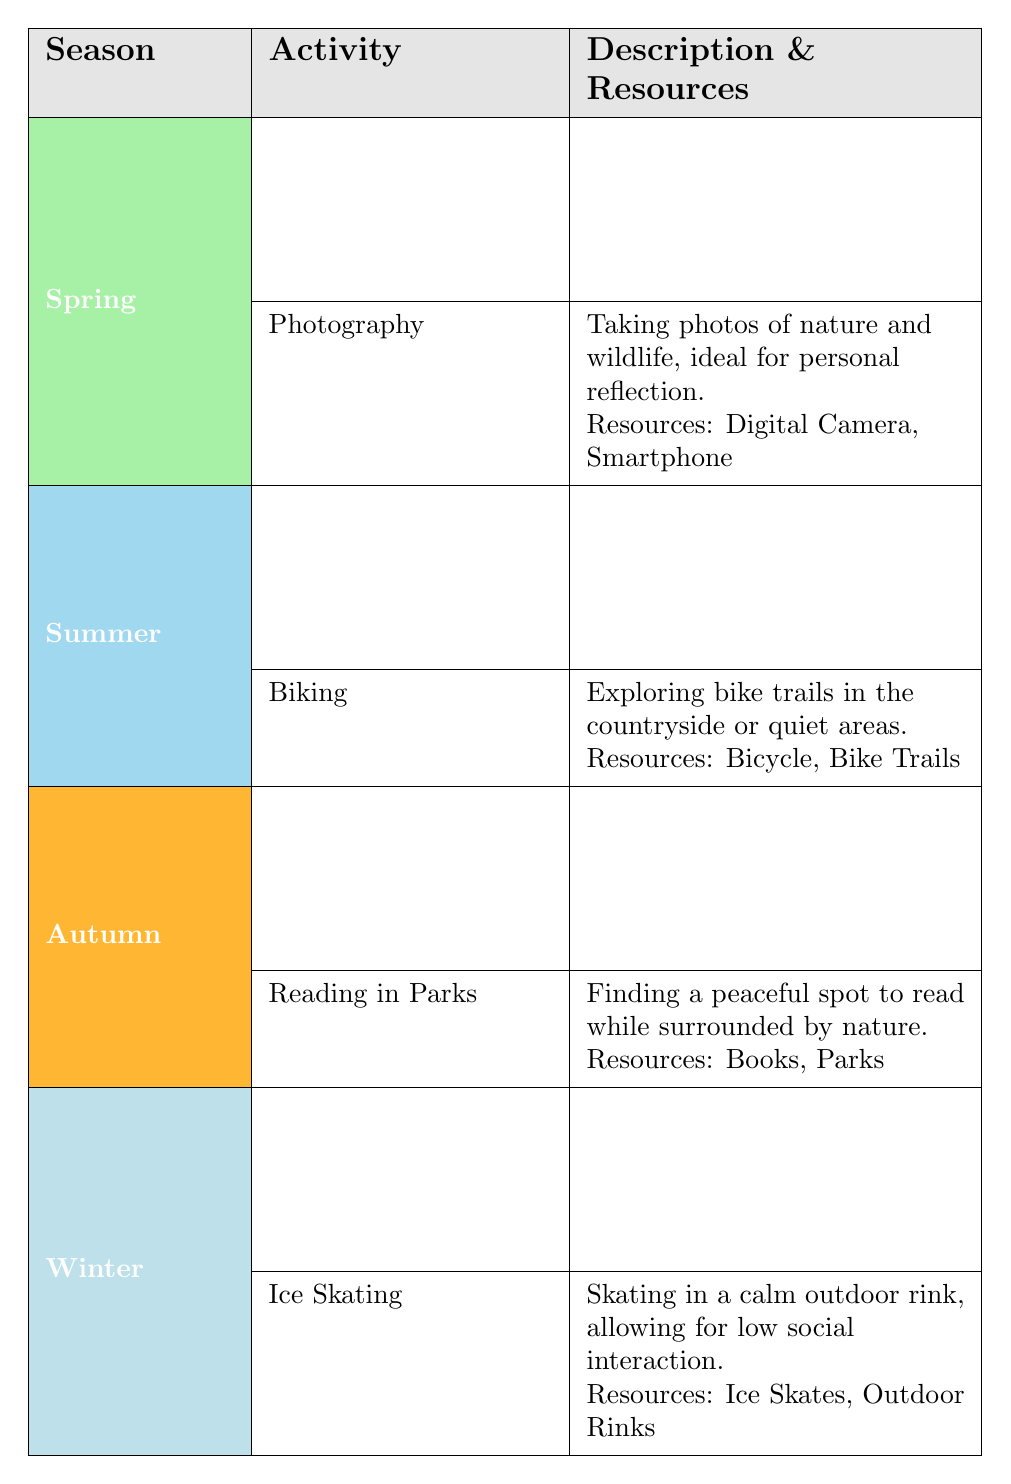What outdoor activity can be enjoyed in Autumn that involves reading? The table shows that "Reading in Parks" is listed under the Autumn season. This activity entails finding a peaceful spot to read while enjoying nature.
Answer: Reading in Parks Which season features "Ice Skating" as an activity? By analyzing the table, it is evident that "Ice Skating" is categorized under Winter.
Answer: Winter Are "Nature Walks" and "Hiking" active during the same season? "Nature Walks" is found in the Spring section, while "Hiking" appears in the Autumn section. Therefore, they are not active during the same season.
Answer: No How many activities are listed for the Summer season? The table indicates that there are two activities listed under Summer: "Camping" and "Biking." Thus, the count is two.
Answer: 2 Is "Photography" considered an outdoor activity for introverted teens? Yes, the table states that "Photography" is an outdoor activity during Spring that is ideal for personal reflection, aligning with the preferences of introverted teens.
Answer: Yes What resources are needed for "Snowshoeing"? Looking in the Winter section, the resources listed for "Snowshoeing" are "Snowshoes" and "Winter Trails."
Answer: Snowshoes, Winter Trails Which activity is targeted for lower social interaction in Winter? The table specifies "Ice Skating" for Winter, highlighting it as an activity that allows for low social interaction.
Answer: Ice Skating What are the two main resources for "Biking"? The Summer section shows that "Biking" requires a "Bicycle" and "Bike Trails" as resources needed for this activity.
Answer: Bicycle, Bike Trails Which season has the activity focused on enjoying the changing colors of leaves? "Hiking" is the activity mentioned in the Autumn section, specifically associated with experiencing the changing colors of leaves.
Answer: Autumn 